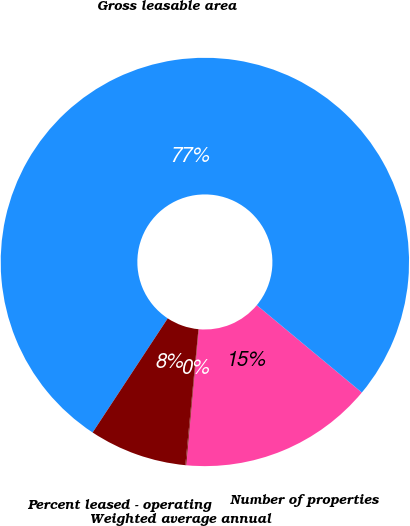Convert chart to OTSL. <chart><loc_0><loc_0><loc_500><loc_500><pie_chart><fcel>Number of properties<fcel>Gross leasable area<fcel>Percent leased - operating<fcel>Weighted average annual<nl><fcel>15.41%<fcel>76.77%<fcel>7.74%<fcel>0.07%<nl></chart> 